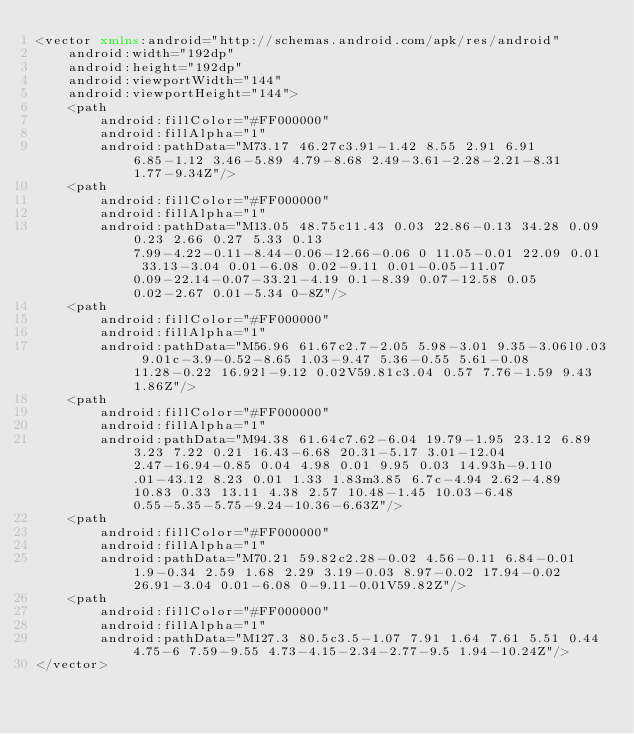Convert code to text. <code><loc_0><loc_0><loc_500><loc_500><_XML_><vector xmlns:android="http://schemas.android.com/apk/res/android"
    android:width="192dp"
    android:height="192dp"
    android:viewportWidth="144"
    android:viewportHeight="144">
    <path
        android:fillColor="#FF000000"
        android:fillAlpha="1"
        android:pathData="M73.17 46.27c3.91-1.42 8.55 2.91 6.91 6.85-1.12 3.46-5.89 4.79-8.68 2.49-3.61-2.28-2.21-8.31 1.77-9.34Z"/>
    <path
        android:fillColor="#FF000000"
        android:fillAlpha="1"
        android:pathData="M13.05 48.75c11.43 0.03 22.86-0.13 34.28 0.09 0.23 2.66 0.27 5.33 0.13 7.99-4.22-0.11-8.44-0.06-12.66-0.06 0 11.05-0.01 22.09 0.01 33.13-3.04 0.01-6.08 0.02-9.11 0.01-0.05-11.07 0.09-22.14-0.07-33.21-4.19 0.1-8.39 0.07-12.58 0.05 0.02-2.67 0.01-5.34 0-8Z"/>
    <path
        android:fillColor="#FF000000"
        android:fillAlpha="1"
        android:pathData="M56.96 61.67c2.7-2.05 5.98-3.01 9.35-3.06l0.03 9.01c-3.9-0.52-8.65 1.03-9.47 5.36-0.55 5.61-0.08 11.28-0.22 16.92l-9.12 0.02V59.81c3.04 0.57 7.76-1.59 9.43 1.86Z"/>
    <path
        android:fillColor="#FF000000"
        android:fillAlpha="1"
        android:pathData="M94.38 61.64c7.62-6.04 19.79-1.95 23.12 6.89 3.23 7.22 0.21 16.43-6.68 20.31-5.17 3.01-12.04 2.47-16.94-0.85 0.04 4.98 0.01 9.95 0.03 14.93h-9.1l0.01-43.12 8.23 0.01 1.33 1.83m3.85 6.7c-4.94 2.62-4.89 10.83 0.33 13.11 4.38 2.57 10.48-1.45 10.03-6.48 0.55-5.35-5.75-9.24-10.36-6.63Z"/>
    <path
        android:fillColor="#FF000000"
        android:fillAlpha="1"
        android:pathData="M70.21 59.82c2.28-0.02 4.56-0.11 6.84-0.01 1.9-0.34 2.59 1.68 2.29 3.19-0.03 8.97-0.02 17.94-0.02 26.91-3.04 0.01-6.08 0-9.11-0.01V59.82Z"/>
    <path
        android:fillColor="#FF000000"
        android:fillAlpha="1"
        android:pathData="M127.3 80.5c3.5-1.07 7.91 1.64 7.61 5.51 0.44 4.75-6 7.59-9.55 4.73-4.15-2.34-2.77-9.5 1.94-10.24Z"/>
</vector>
</code> 